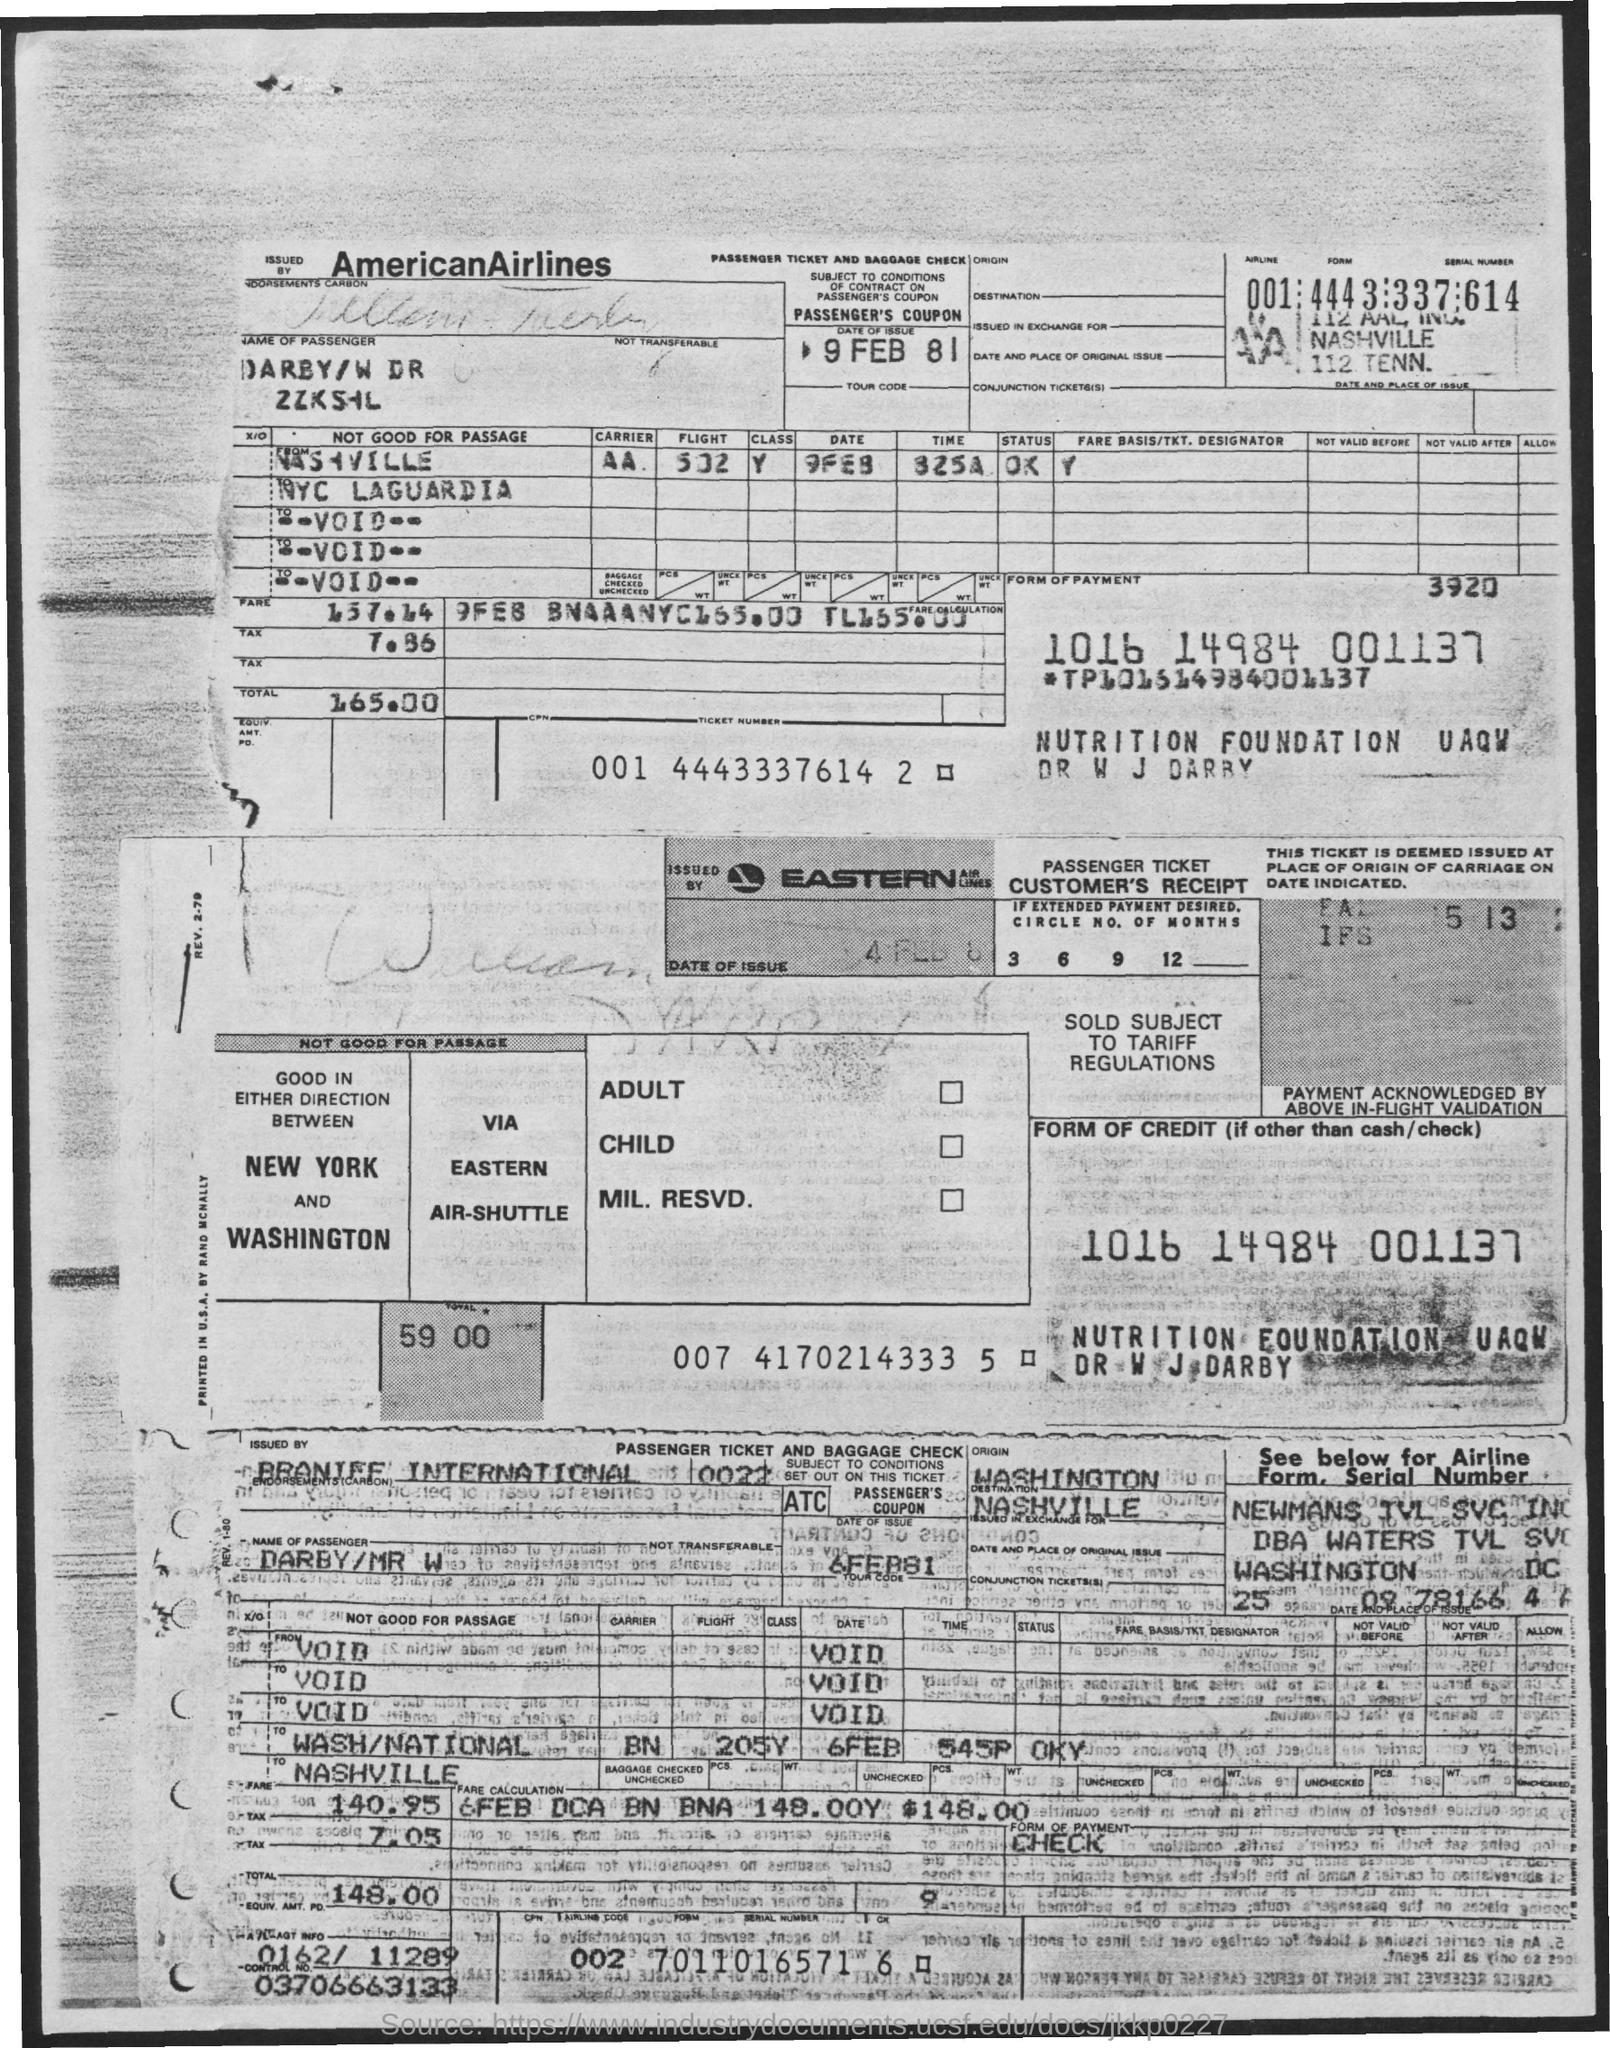What is the control number?
Give a very brief answer. 03706663133. What is the date of the issue of American Airlines' passenger ticket?
Your answer should be compact. 9 Feb 81. What is the date of the issue of Eastern Airlines passenger ticket?
Your answer should be compact. 6FEB81. What is the Airline code of American Airlines?
Your answer should be very brief. 001. 